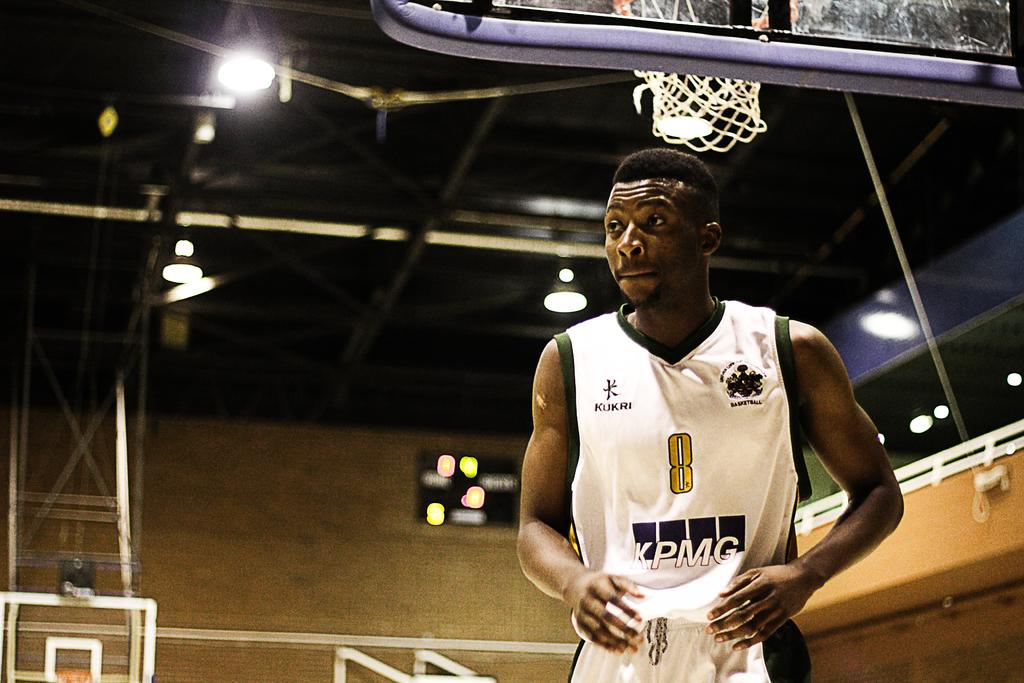<image>
Share a concise interpretation of the image provided. A basketball player with the letters KPMG on the front of his jersey is walking underneath the basketball net. 